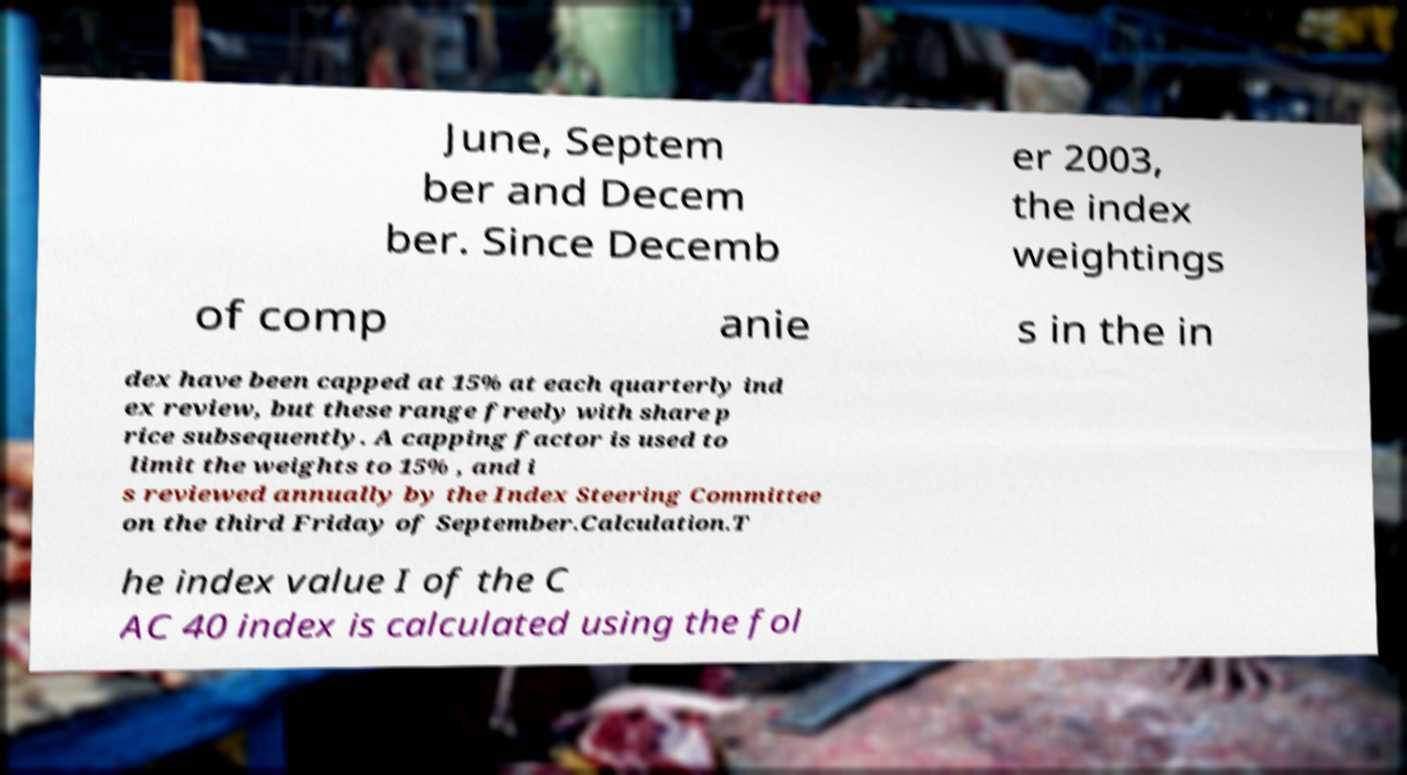There's text embedded in this image that I need extracted. Can you transcribe it verbatim? June, Septem ber and Decem ber. Since Decemb er 2003, the index weightings of comp anie s in the in dex have been capped at 15% at each quarterly ind ex review, but these range freely with share p rice subsequently. A capping factor is used to limit the weights to 15% , and i s reviewed annually by the Index Steering Committee on the third Friday of September.Calculation.T he index value I of the C AC 40 index is calculated using the fol 